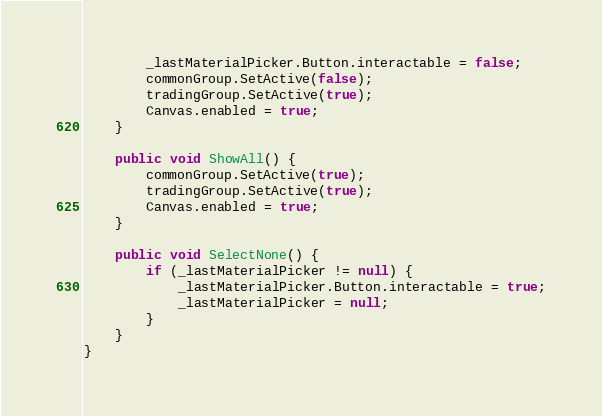Convert code to text. <code><loc_0><loc_0><loc_500><loc_500><_C#_>        _lastMaterialPicker.Button.interactable = false;
        commonGroup.SetActive(false);
        tradingGroup.SetActive(true);
        Canvas.enabled = true;
    }

    public void ShowAll() {
        commonGroup.SetActive(true);
        tradingGroup.SetActive(true);
        Canvas.enabled = true;
    }

    public void SelectNone() {
        if (_lastMaterialPicker != null) {
            _lastMaterialPicker.Button.interactable = true;
            _lastMaterialPicker = null;
        }
    }
}</code> 